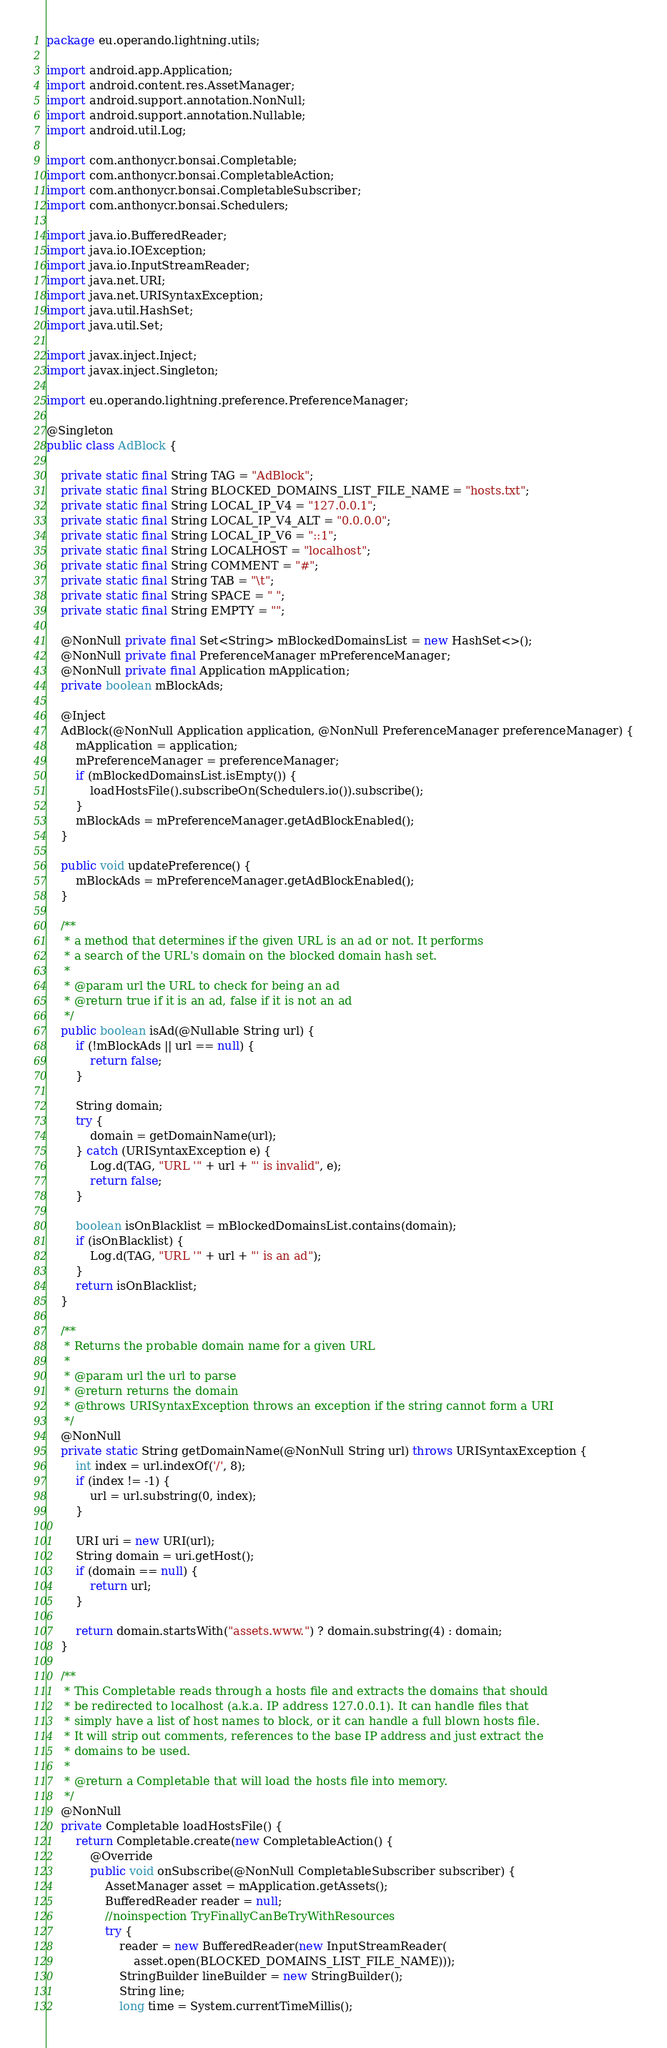<code> <loc_0><loc_0><loc_500><loc_500><_Java_>package eu.operando.lightning.utils;

import android.app.Application;
import android.content.res.AssetManager;
import android.support.annotation.NonNull;
import android.support.annotation.Nullable;
import android.util.Log;

import com.anthonycr.bonsai.Completable;
import com.anthonycr.bonsai.CompletableAction;
import com.anthonycr.bonsai.CompletableSubscriber;
import com.anthonycr.bonsai.Schedulers;

import java.io.BufferedReader;
import java.io.IOException;
import java.io.InputStreamReader;
import java.net.URI;
import java.net.URISyntaxException;
import java.util.HashSet;
import java.util.Set;

import javax.inject.Inject;
import javax.inject.Singleton;

import eu.operando.lightning.preference.PreferenceManager;

@Singleton
public class AdBlock {

    private static final String TAG = "AdBlock";
    private static final String BLOCKED_DOMAINS_LIST_FILE_NAME = "hosts.txt";
    private static final String LOCAL_IP_V4 = "127.0.0.1";
    private static final String LOCAL_IP_V4_ALT = "0.0.0.0";
    private static final String LOCAL_IP_V6 = "::1";
    private static final String LOCALHOST = "localhost";
    private static final String COMMENT = "#";
    private static final String TAB = "\t";
    private static final String SPACE = " ";
    private static final String EMPTY = "";

    @NonNull private final Set<String> mBlockedDomainsList = new HashSet<>();
    @NonNull private final PreferenceManager mPreferenceManager;
    @NonNull private final Application mApplication;
    private boolean mBlockAds;

    @Inject
    AdBlock(@NonNull Application application, @NonNull PreferenceManager preferenceManager) {
        mApplication = application;
        mPreferenceManager = preferenceManager;
        if (mBlockedDomainsList.isEmpty()) {
            loadHostsFile().subscribeOn(Schedulers.io()).subscribe();
        }
        mBlockAds = mPreferenceManager.getAdBlockEnabled();
    }

    public void updatePreference() {
        mBlockAds = mPreferenceManager.getAdBlockEnabled();
    }

    /**
     * a method that determines if the given URL is an ad or not. It performs
     * a search of the URL's domain on the blocked domain hash set.
     *
     * @param url the URL to check for being an ad
     * @return true if it is an ad, false if it is not an ad
     */
    public boolean isAd(@Nullable String url) {
        if (!mBlockAds || url == null) {
            return false;
        }

        String domain;
        try {
            domain = getDomainName(url);
        } catch (URISyntaxException e) {
            Log.d(TAG, "URL '" + url + "' is invalid", e);
            return false;
        }

        boolean isOnBlacklist = mBlockedDomainsList.contains(domain);
        if (isOnBlacklist) {
            Log.d(TAG, "URL '" + url + "' is an ad");
        }
        return isOnBlacklist;
    }

    /**
     * Returns the probable domain name for a given URL
     *
     * @param url the url to parse
     * @return returns the domain
     * @throws URISyntaxException throws an exception if the string cannot form a URI
     */
    @NonNull
    private static String getDomainName(@NonNull String url) throws URISyntaxException {
        int index = url.indexOf('/', 8);
        if (index != -1) {
            url = url.substring(0, index);
        }

        URI uri = new URI(url);
        String domain = uri.getHost();
        if (domain == null) {
            return url;
        }

        return domain.startsWith("assets.www.") ? domain.substring(4) : domain;
    }

    /**
     * This Completable reads through a hosts file and extracts the domains that should
     * be redirected to localhost (a.k.a. IP address 127.0.0.1). It can handle files that
     * simply have a list of host names to block, or it can handle a full blown hosts file.
     * It will strip out comments, references to the base IP address and just extract the
     * domains to be used.
     *
     * @return a Completable that will load the hosts file into memory.
     */
    @NonNull
    private Completable loadHostsFile() {
        return Completable.create(new CompletableAction() {
            @Override
            public void onSubscribe(@NonNull CompletableSubscriber subscriber) {
                AssetManager asset = mApplication.getAssets();
                BufferedReader reader = null;
                //noinspection TryFinallyCanBeTryWithResources
                try {
                    reader = new BufferedReader(new InputStreamReader(
                        asset.open(BLOCKED_DOMAINS_LIST_FILE_NAME)));
                    StringBuilder lineBuilder = new StringBuilder();
                    String line;
                    long time = System.currentTimeMillis();
</code> 